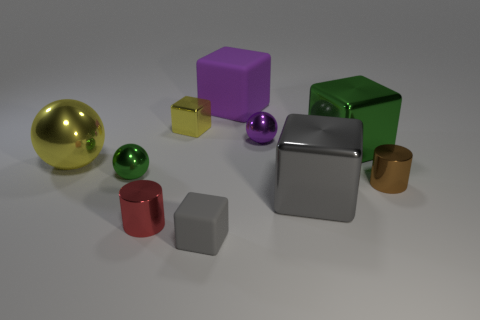Can you tell me about the different materials shown in the objects of this image? Certainly! The image displays a collection of objects with varying materials. The sphere and the cylinder appear to have a metallic finish, indicative of materials like steel or aluminum, giving off a reflective surface. The cube and the rectangular block have matte surfaces possibly suggesting a plastic or painted wood composition. The lighting in the scene highlights these material differences, enhancing their textures and colors. 